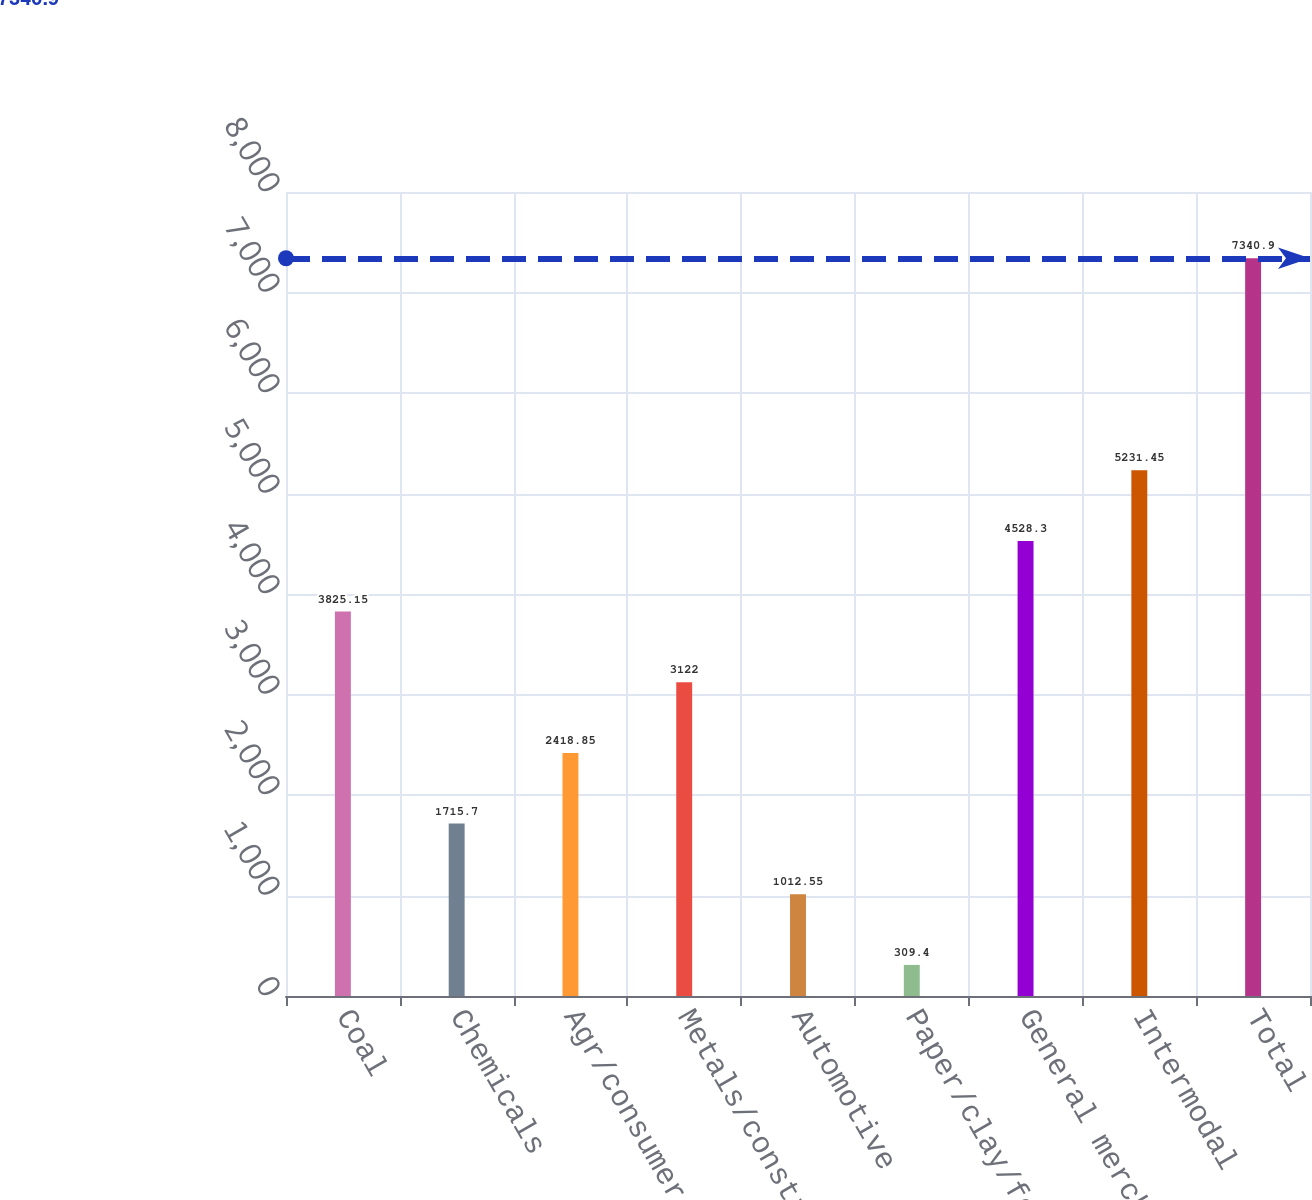Convert chart. <chart><loc_0><loc_0><loc_500><loc_500><bar_chart><fcel>Coal<fcel>Chemicals<fcel>Agr/consumer/gov't<fcel>Metals/construction<fcel>Automotive<fcel>Paper/clay/forest<fcel>General merchandise<fcel>Intermodal<fcel>Total<nl><fcel>3825.15<fcel>1715.7<fcel>2418.85<fcel>3122<fcel>1012.55<fcel>309.4<fcel>4528.3<fcel>5231.45<fcel>7340.9<nl></chart> 